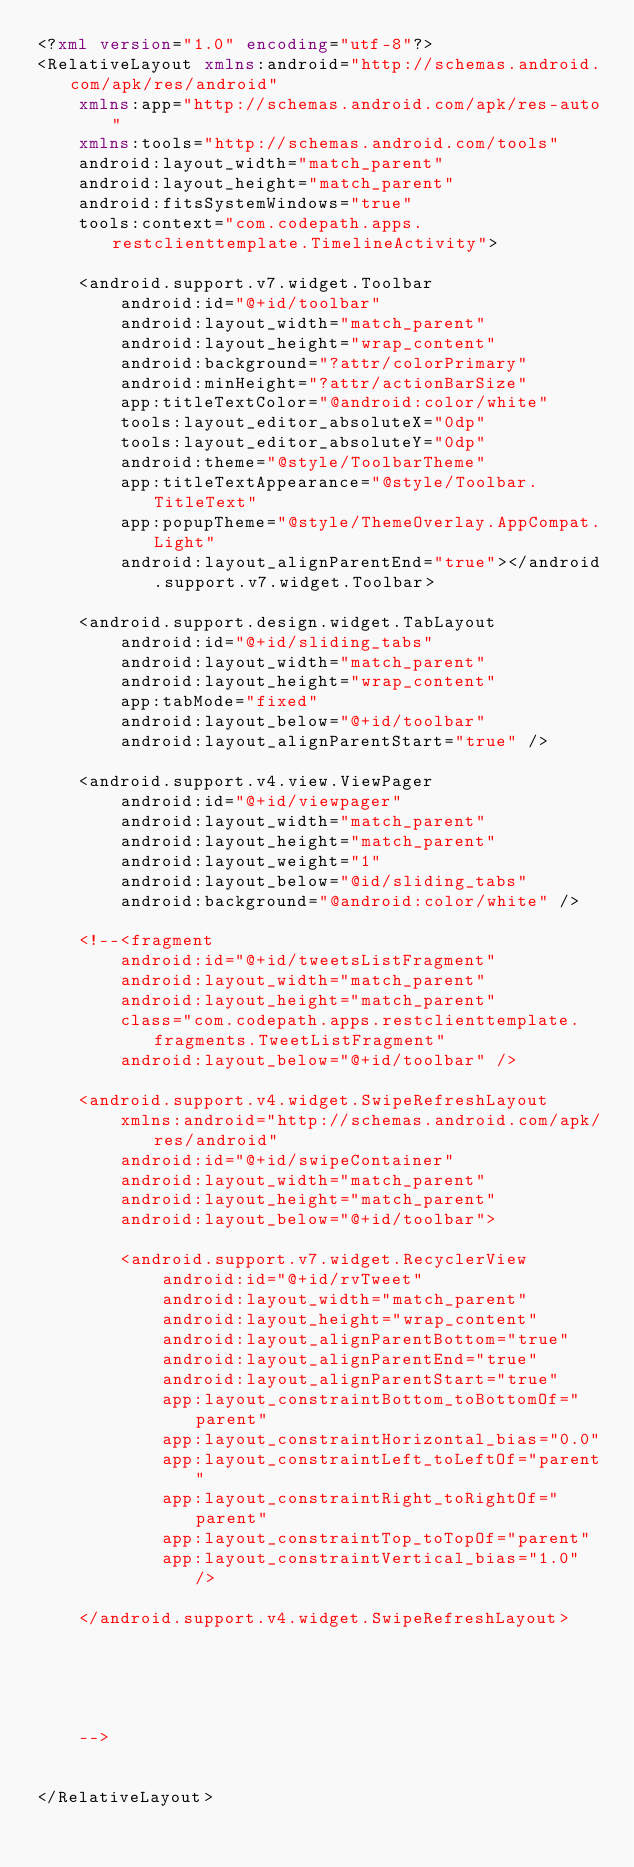Convert code to text. <code><loc_0><loc_0><loc_500><loc_500><_XML_><?xml version="1.0" encoding="utf-8"?>
<RelativeLayout xmlns:android="http://schemas.android.com/apk/res/android"
    xmlns:app="http://schemas.android.com/apk/res-auto"
    xmlns:tools="http://schemas.android.com/tools"
    android:layout_width="match_parent"
    android:layout_height="match_parent"
    android:fitsSystemWindows="true"
    tools:context="com.codepath.apps.restclienttemplate.TimelineActivity">

    <android.support.v7.widget.Toolbar
        android:id="@+id/toolbar"
        android:layout_width="match_parent"
        android:layout_height="wrap_content"
        android:background="?attr/colorPrimary"
        android:minHeight="?attr/actionBarSize"
        app:titleTextColor="@android:color/white"
        tools:layout_editor_absoluteX="0dp"
        tools:layout_editor_absoluteY="0dp"
        android:theme="@style/ToolbarTheme"
        app:titleTextAppearance="@style/Toolbar.TitleText"
        app:popupTheme="@style/ThemeOverlay.AppCompat.Light"
        android:layout_alignParentEnd="true"></android.support.v7.widget.Toolbar>

    <android.support.design.widget.TabLayout
        android:id="@+id/sliding_tabs"
        android:layout_width="match_parent"
        android:layout_height="wrap_content"
        app:tabMode="fixed"
        android:layout_below="@+id/toolbar"
        android:layout_alignParentStart="true" />

    <android.support.v4.view.ViewPager
        android:id="@+id/viewpager"
        android:layout_width="match_parent"
        android:layout_height="match_parent"
        android:layout_weight="1"
        android:layout_below="@id/sliding_tabs"
        android:background="@android:color/white" />

    <!--<fragment
        android:id="@+id/tweetsListFragment"
        android:layout_width="match_parent"
        android:layout_height="match_parent"
        class="com.codepath.apps.restclienttemplate.fragments.TweetListFragment"
        android:layout_below="@+id/toolbar" />

    <android.support.v4.widget.SwipeRefreshLayout
        xmlns:android="http://schemas.android.com/apk/res/android"
        android:id="@+id/swipeContainer"
        android:layout_width="match_parent"
        android:layout_height="match_parent"
        android:layout_below="@+id/toolbar">

        <android.support.v7.widget.RecyclerView
            android:id="@+id/rvTweet"
            android:layout_width="match_parent"
            android:layout_height="wrap_content"
            android:layout_alignParentBottom="true"
            android:layout_alignParentEnd="true"
            android:layout_alignParentStart="true"
            app:layout_constraintBottom_toBottomOf="parent"
            app:layout_constraintHorizontal_bias="0.0"
            app:layout_constraintLeft_toLeftOf="parent"
            app:layout_constraintRight_toRightOf="parent"
            app:layout_constraintTop_toTopOf="parent"
            app:layout_constraintVertical_bias="1.0" />

    </android.support.v4.widget.SwipeRefreshLayout>





    -->


</RelativeLayout>
</code> 